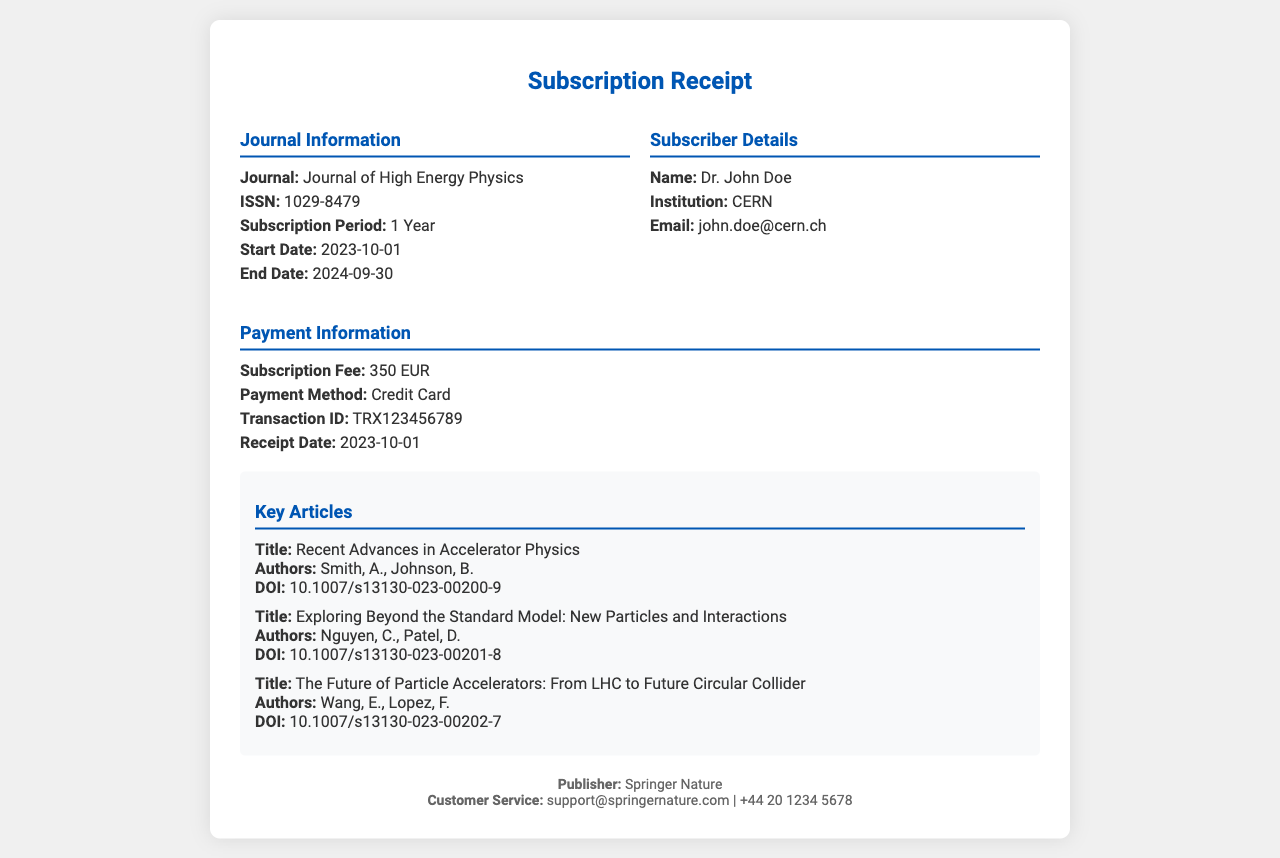What is the journal name? The journal name is provided in the document under "Journal Information."
Answer: Journal of High Energy Physics What is the ISSN number? The ISSN number is a unique identifier for the journal listed in the document.
Answer: 1029-8479 What is the subscription fee? The subscription fee is specified under "Payment Information" in the receipt.
Answer: 350 EUR Who is the subscriber's name? The subscriber's name is provided in the "Subscriber Details" section of the document.
Answer: Dr. John Doe What is the payment method? The payment method is mentioned in the "Payment Information" section of the receipt.
Answer: Credit Card When does the subscription end? The end date of the subscription is provided in the "Journal Information" section.
Answer: 2024-09-30 What is the transaction ID? The transaction ID is listed under "Payment Information" in the receipt.
Answer: TRX123456789 What is one of the key article titles? Key article titles are specified under the "Key Articles" section, and one can be chosen.
Answer: Recent Advances in Accelerator Physics How long is the subscription period? The subscription period is explicitly stated in the "Journal Information" section of the receipt.
Answer: 1 Year 